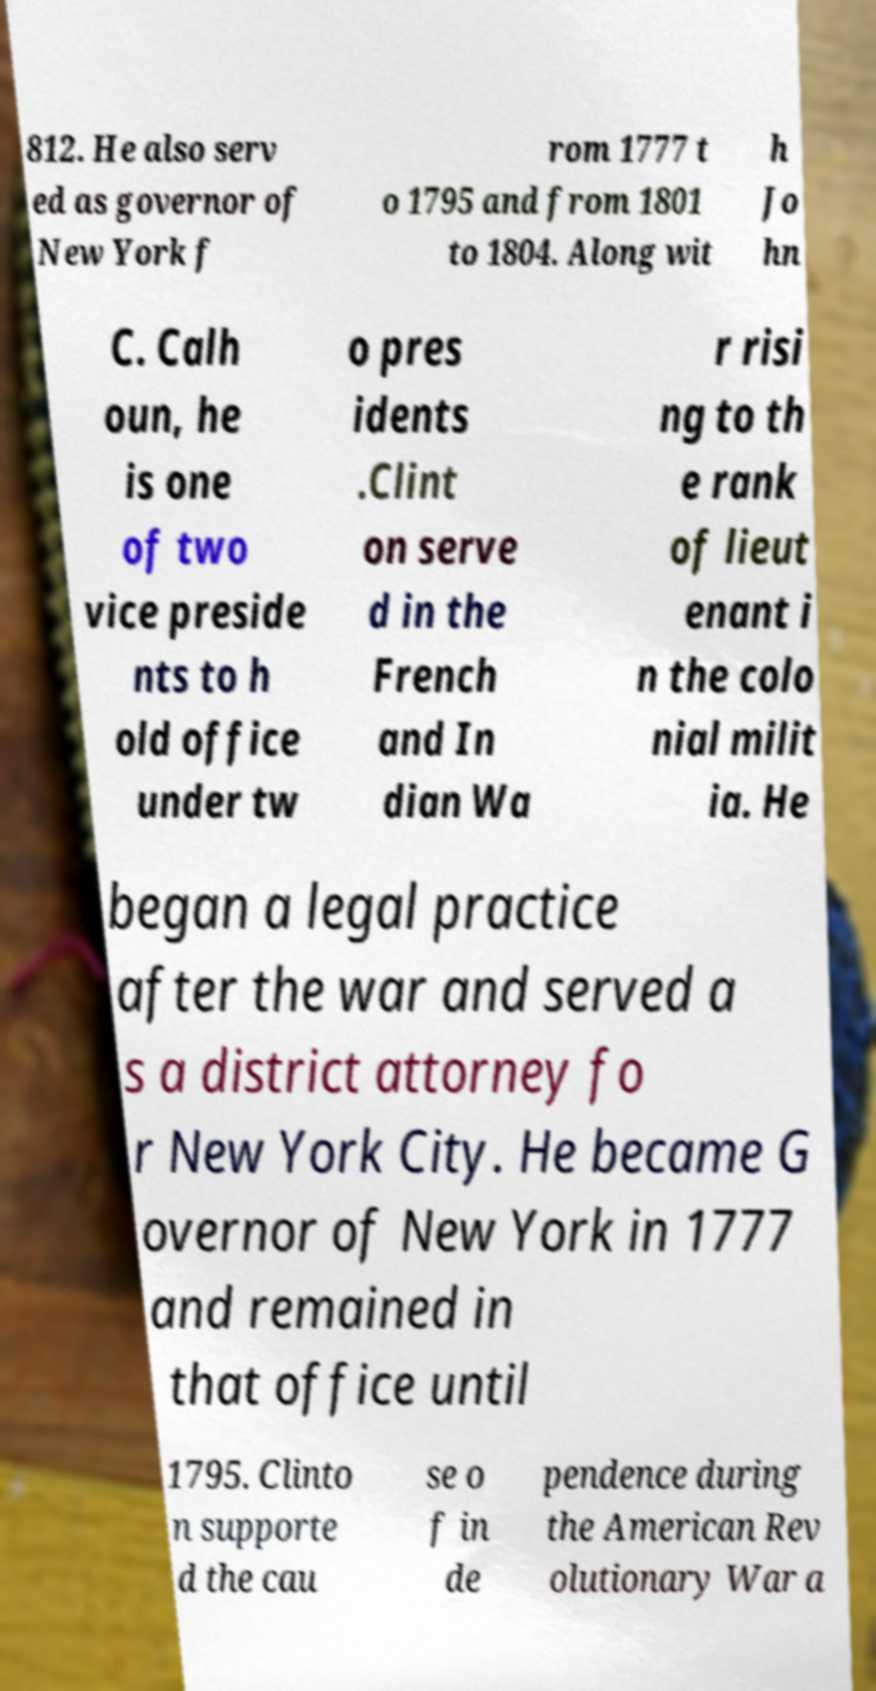What messages or text are displayed in this image? I need them in a readable, typed format. 812. He also serv ed as governor of New York f rom 1777 t o 1795 and from 1801 to 1804. Along wit h Jo hn C. Calh oun, he is one of two vice preside nts to h old office under tw o pres idents .Clint on serve d in the French and In dian Wa r risi ng to th e rank of lieut enant i n the colo nial milit ia. He began a legal practice after the war and served a s a district attorney fo r New York City. He became G overnor of New York in 1777 and remained in that office until 1795. Clinto n supporte d the cau se o f in de pendence during the American Rev olutionary War a 